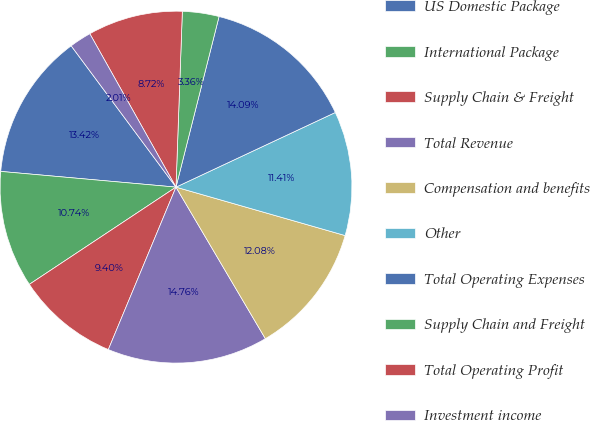Convert chart to OTSL. <chart><loc_0><loc_0><loc_500><loc_500><pie_chart><fcel>US Domestic Package<fcel>International Package<fcel>Supply Chain & Freight<fcel>Total Revenue<fcel>Compensation and benefits<fcel>Other<fcel>Total Operating Expenses<fcel>Supply Chain and Freight<fcel>Total Operating Profit<fcel>Investment income<nl><fcel>13.42%<fcel>10.74%<fcel>9.4%<fcel>14.76%<fcel>12.08%<fcel>11.41%<fcel>14.09%<fcel>3.36%<fcel>8.72%<fcel>2.01%<nl></chart> 